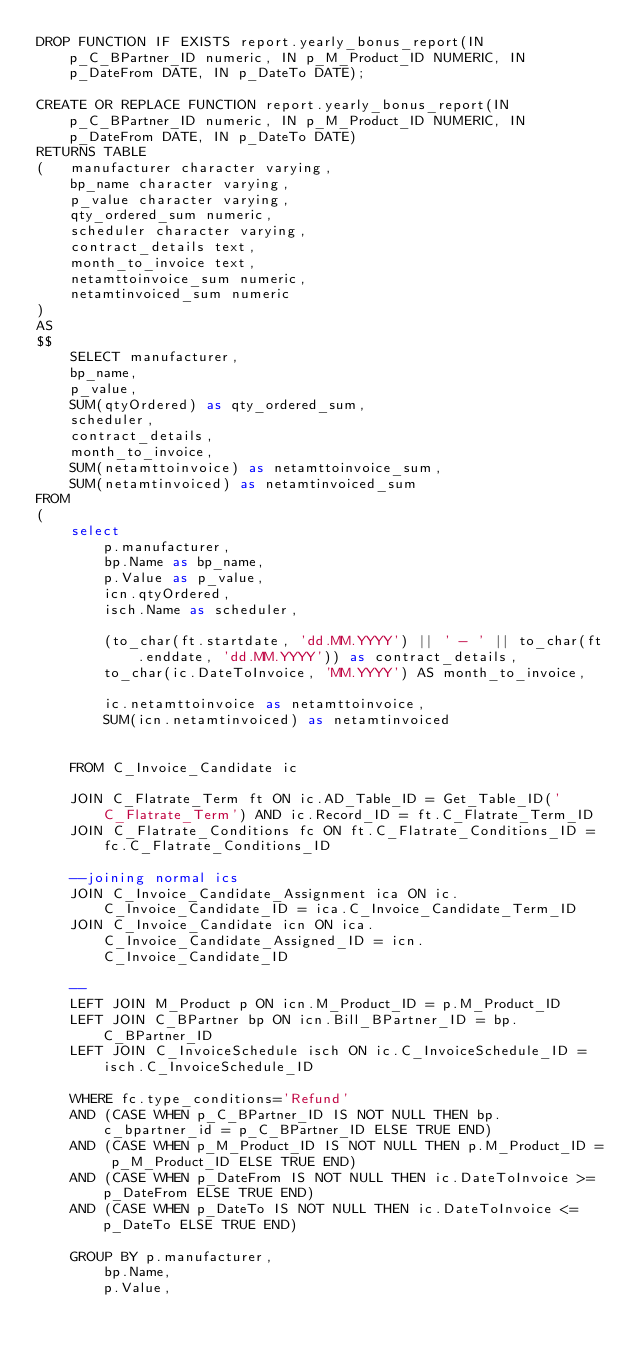Convert code to text. <code><loc_0><loc_0><loc_500><loc_500><_SQL_>DROP FUNCTION IF EXISTS report.yearly_bonus_report(IN p_C_BPartner_ID numeric, IN p_M_Product_ID NUMERIC, IN p_DateFrom DATE, IN p_DateTo DATE);

CREATE OR REPLACE FUNCTION report.yearly_bonus_report(IN p_C_BPartner_ID numeric, IN p_M_Product_ID NUMERIC, IN p_DateFrom DATE, IN p_DateTo DATE)
RETURNS TABLE
(	manufacturer character varying,
	bp_name character varying,
	p_value character varying,
	qty_ordered_sum numeric,
	scheduler character varying,
	contract_details text,
	month_to_invoice text,
	netamttoinvoice_sum numeric,
	netamtinvoiced_sum numeric
)
AS
$$
	SELECT manufacturer, 
	bp_name, 
	p_value, 
	SUM(qtyOrdered) as qty_ordered_sum, 
	scheduler, 
	contract_details, 
	month_to_invoice, 
	SUM(netamttoinvoice) as netamttoinvoice_sum, 
	SUM(netamtinvoiced) as netamtinvoiced_sum
FROM	
(
	select 
		p.manufacturer, 
		bp.Name as bp_name, 
		p.Value as p_value, 
		icn.qtyOrdered, 
		isch.Name as scheduler, 
		
		(to_char(ft.startdate, 'dd.MM.YYYY') || ' - ' || to_char(ft.enddate, 'dd.MM.YYYY')) as contract_details, 
		to_char(ic.DateToInvoice, 'MM.YYYY') AS month_to_invoice, 
		
		ic.netamttoinvoice as netamttoinvoice,
		SUM(icn.netamtinvoiced) as netamtinvoiced
		

	FROM C_Invoice_Candidate ic

	JOIN C_Flatrate_Term ft ON ic.AD_Table_ID = Get_Table_ID('C_Flatrate_Term') AND ic.Record_ID = ft.C_Flatrate_Term_ID
	JOIN C_Flatrate_Conditions fc ON ft.C_Flatrate_Conditions_ID = fc.C_Flatrate_Conditions_ID
	
	--joining normal ics
	JOIN C_Invoice_Candidate_Assignment ica ON ic.C_Invoice_Candidate_ID = ica.C_Invoice_Candidate_Term_ID
	JOIN C_Invoice_Candidate icn ON ica.C_Invoice_Candidate_Assigned_ID = icn.C_Invoice_Candidate_ID
	
	--
	LEFT JOIN M_Product p ON icn.M_Product_ID = p.M_Product_ID
	LEFT JOIN C_BPartner bp ON icn.Bill_BPartner_ID = bp.C_BPartner_ID
	LEFT JOIN C_InvoiceSchedule isch ON ic.C_InvoiceSchedule_ID = isch.C_InvoiceSchedule_ID

	WHERE fc.type_conditions='Refund' 
	AND (CASE WHEN p_C_BPartner_ID IS NOT NULL THEN bp.c_bpartner_id = p_C_BPartner_ID ELSE TRUE END)
	AND (CASE WHEN p_M_Product_ID IS NOT NULL THEN p.M_Product_ID = p_M_Product_ID ELSE TRUE END)
	AND (CASE WHEN p_DateFrom IS NOT NULL THEN ic.DateToInvoice >= p_DateFrom ELSE TRUE END)
	AND (CASE WHEN p_DateTo IS NOT NULL THEN ic.DateToInvoice <= p_DateTo ELSE TRUE END)

	GROUP BY p.manufacturer, 
		bp.Name,
		p.Value, </code> 